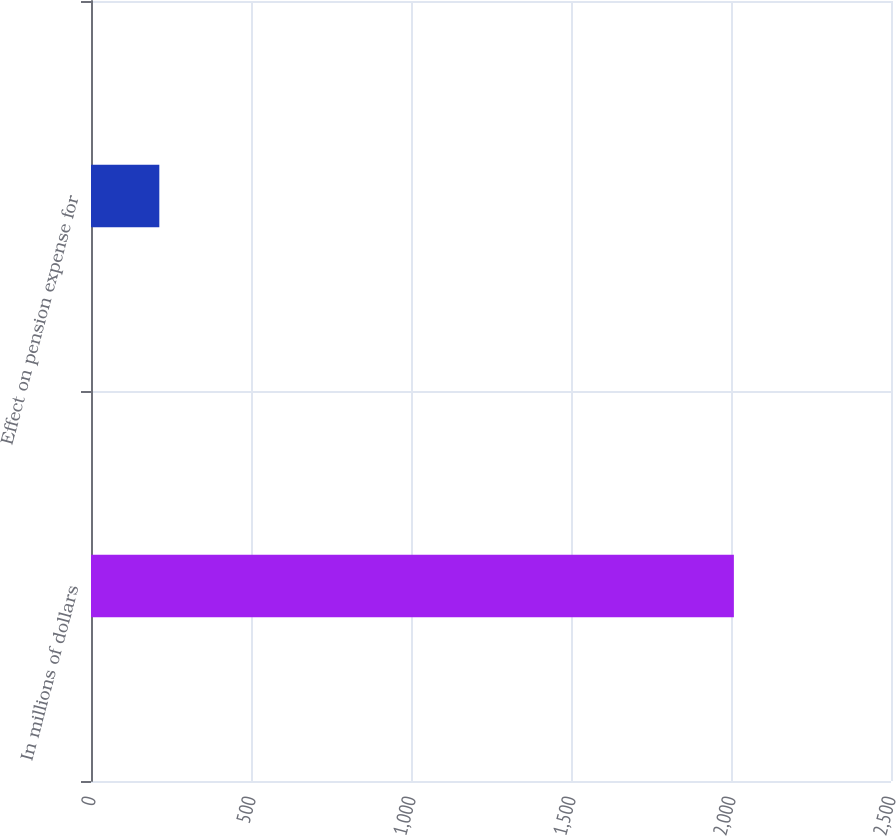Convert chart to OTSL. <chart><loc_0><loc_0><loc_500><loc_500><bar_chart><fcel>In millions of dollars<fcel>Effect on pension expense for<nl><fcel>2009<fcel>213.5<nl></chart> 